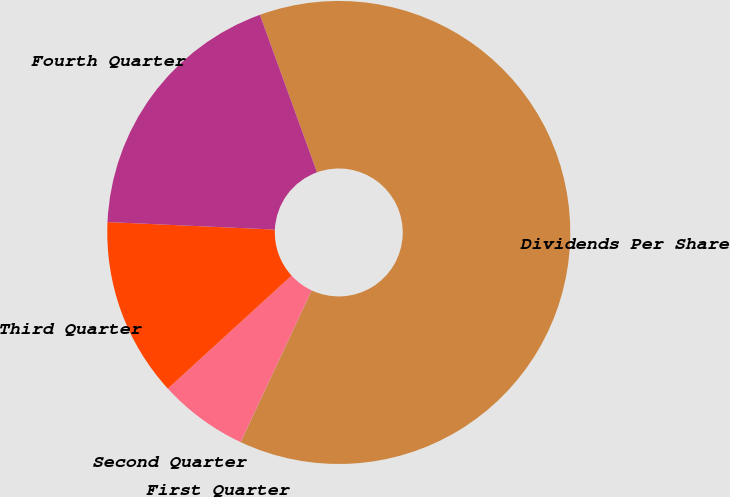Convert chart. <chart><loc_0><loc_0><loc_500><loc_500><pie_chart><fcel>Dividends Per Share<fcel>First Quarter<fcel>Second Quarter<fcel>Third Quarter<fcel>Fourth Quarter<nl><fcel>62.49%<fcel>0.01%<fcel>6.25%<fcel>12.5%<fcel>18.75%<nl></chart> 